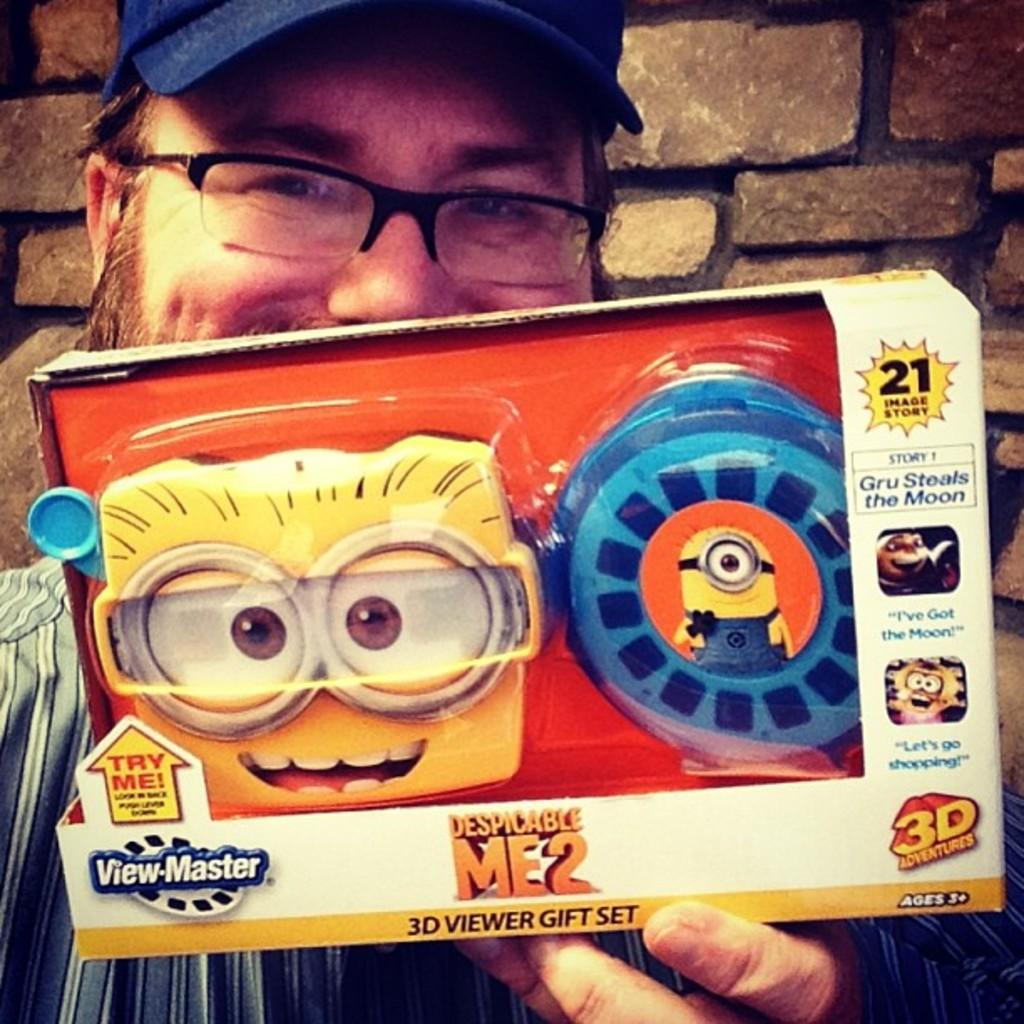What can be seen in the image? There is a person in the image. What is the person doing in the image? The person is holding an object. What can be seen in the background of the image? There is a brick wall in the background of the image. What type of waste can be seen on the moon in the image? There is no waste or moon present in the image; it features a person holding an object in front of a brick wall. 